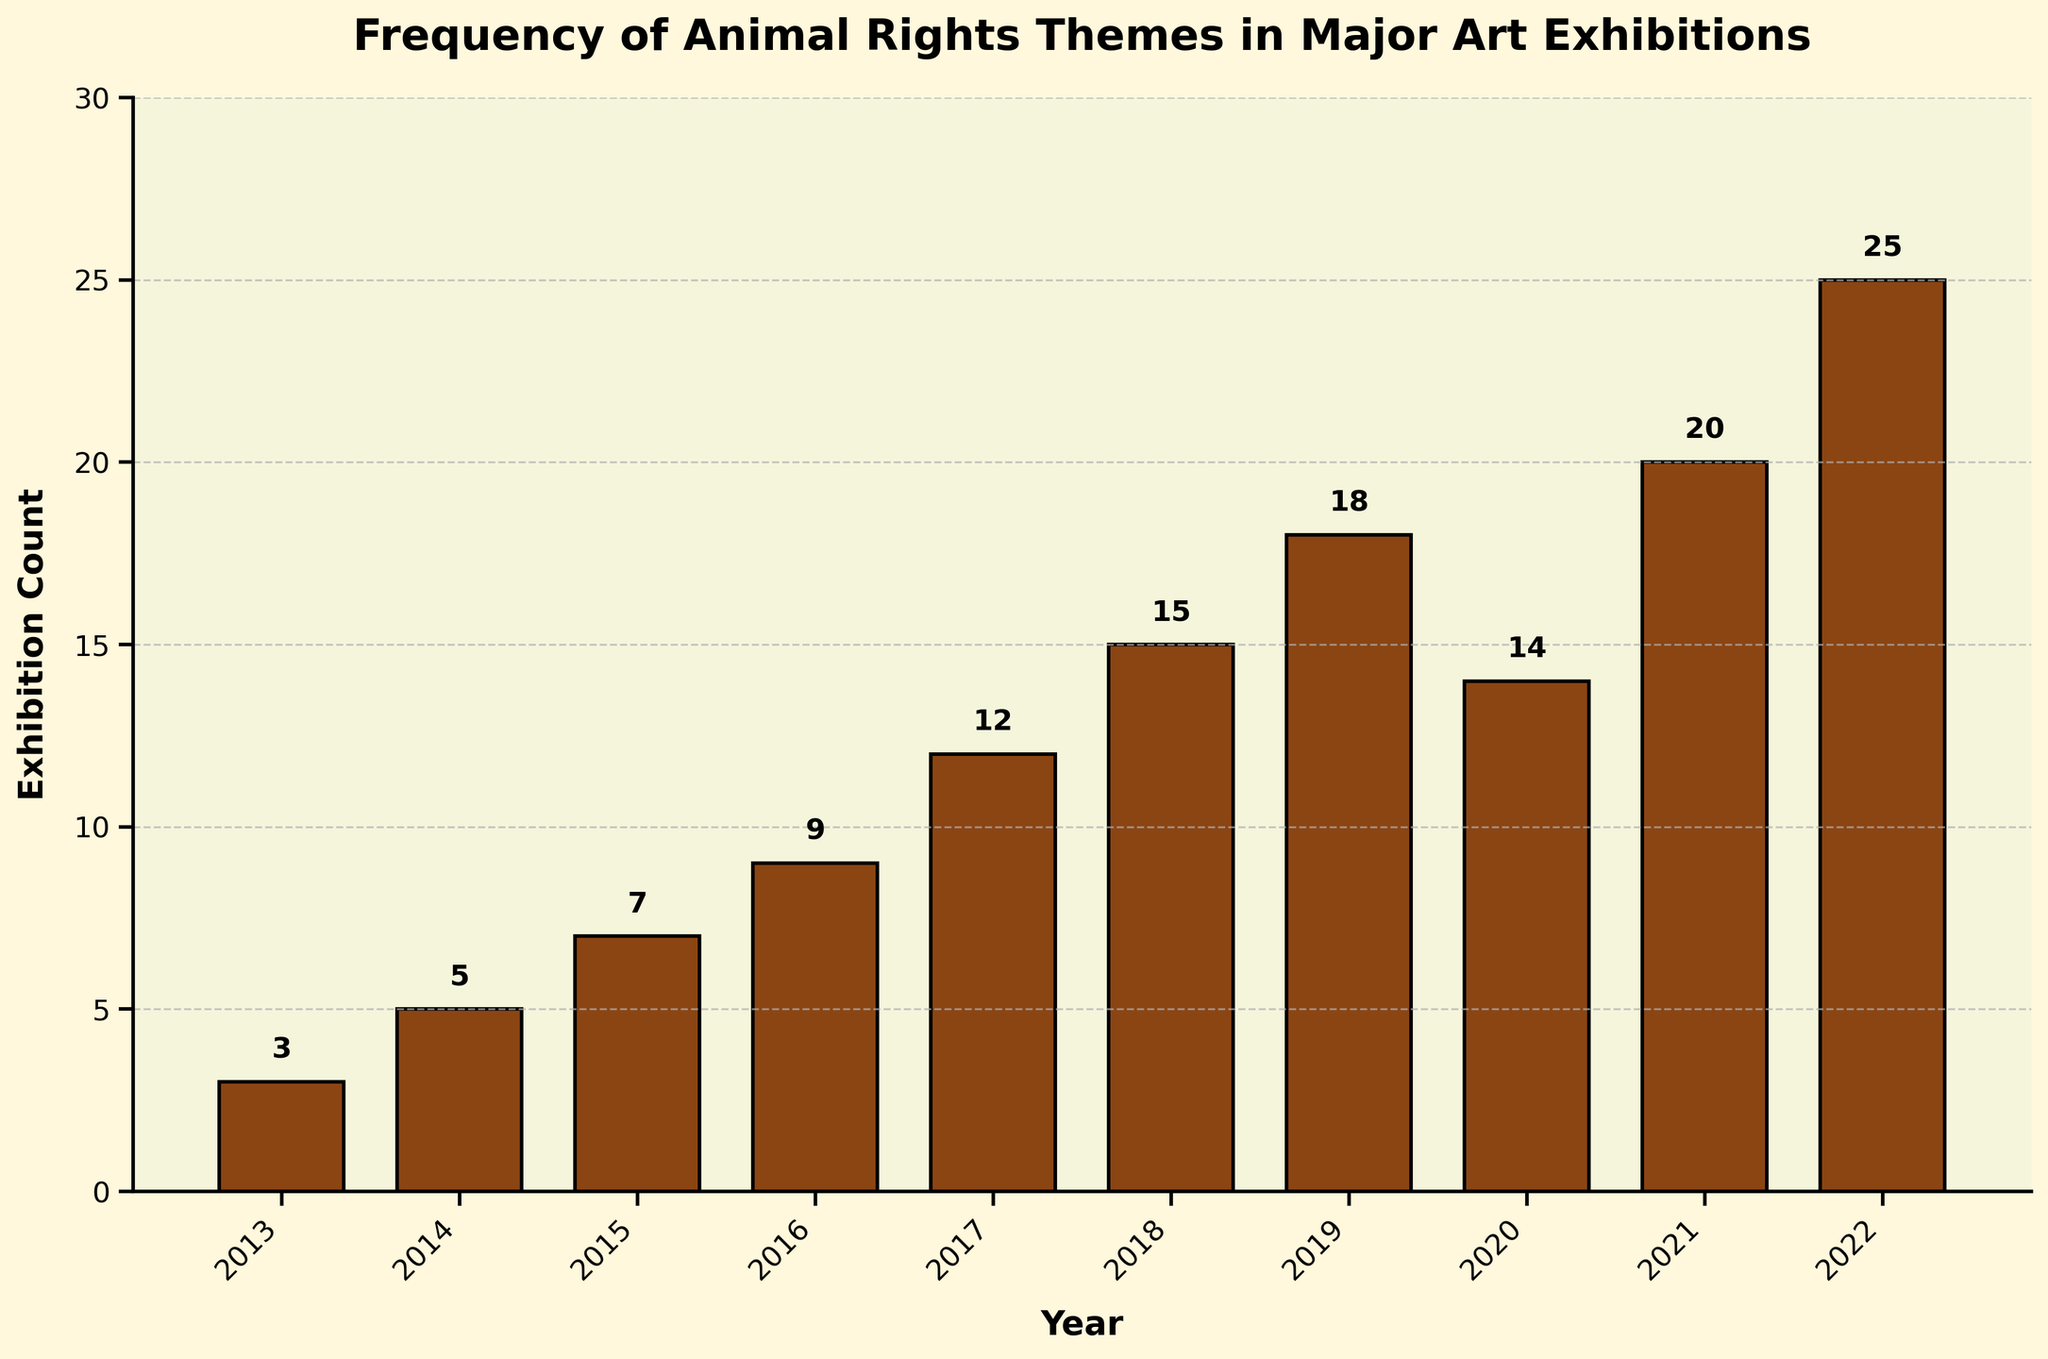Which year had the highest number of exhibitions with animal rights themes? By examining the heights of the bars, the highest bar corresponds to the year 2022. The text label above the bar indicates 25 exhibitions in 2022.
Answer: 2022 How many exhibitions featured animal rights themes in 2016 and 2017 combined? The bar for 2016 shows 9 exhibitions, and the bar for 2017 shows 12 exhibitions. Adding them gives 9 + 12.
Answer: 21 Did the number of exhibitions with animal rights themes increase or decrease from 2019 to 2020? By comparing the heights of the bars for 2019 and 2020, we can see that the bar for 2020 is shorter than the bar for 2019. The text labels show 18 in 2019 and 14 in 2020, indicating a decrease.
Answer: Decrease What is the average number of exhibitions with animal rights themes from 2013 to 2022? Sum the exhibition counts: 3 + 5 + 7 + 9 + 12 + 15 + 18 + 14 + 20 + 25 = 128. Divide the sum by the number of years (10): 128 / 10.
Answer: 12.8 Which year saw the largest increase in exhibitions with animal rights themes compared to the previous year? Calculate the annual differences: 
2014 - 2013 = 2,
2015 - 2014 = 2,
2016 - 2015 = 2,
2017 - 2016 = 3,
2018 - 2017 = 3,
2019 - 2018 = 3,
2020 - 2019 = -4,
2021 - 2020 = 6,
2022 - 2021 = 5.
The largest increase is from 2020 to 2021, with a difference of 6.
Answer: 2021 What is the median number of exhibitions with animal rights themes over the period shown? Arrange the counts in ascending order: 3, 5, 7, 9, 12, 14, 15, 18, 20, 25. The median is the middle value in this ordered list, between 12 and 14. (12 + 14)/2 = 13.
Answer: 13 Which year had an equal number of exhibitions with animal rights themes compared to 2018? The bar for 2018 shows 15 exhibitions. By comparing this to other bars, there is no other year with 15 exhibitions.
Answer: None How many years had fewer than 10 exhibitions featuring animal rights themes? By counting the bars with heights below the 10-exhibition mark, we find the years 2013 (3), 2014 (5), 2015 (7), and 2016 (9)—four years in total.
Answer: 4 What trend can you observe from 2013 to 2022 regarding the number of exhibitions with animal rights themes? By observing the progression of bar heights from 2013 to 2022, there is a general upward trend, except for a slight decline from 2019 to 2020.
Answer: Overall increase How does the exhibition count in 2020 relate to that in 2021? By comparing the heights of the two bars, the bar for 2021 is taller than the bar for 2020, indicating an increase. Numerically, 2021 (20) had an increase of 6 exhibitions from 2020 (14).
Answer: Increase 